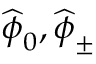Convert formula to latex. <formula><loc_0><loc_0><loc_500><loc_500>\widehat { \phi } _ { 0 } , \widehat { \phi } _ { \pm }</formula> 